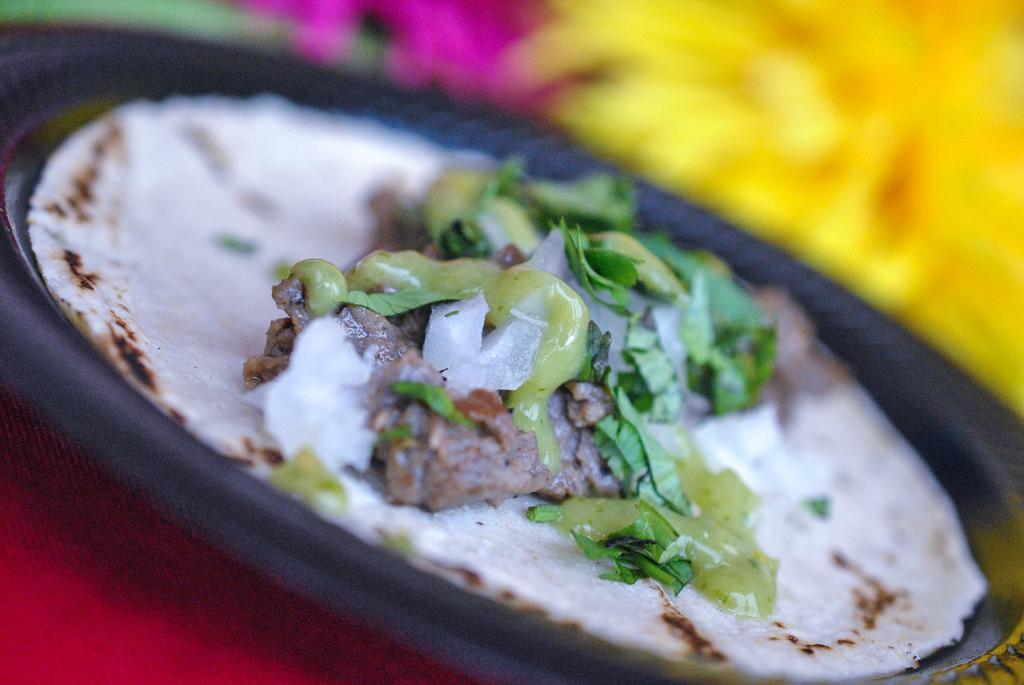In one or two sentences, can you explain what this image depicts? There is an edible placed on a black plate and there is an yellow color object in the right top corner. 